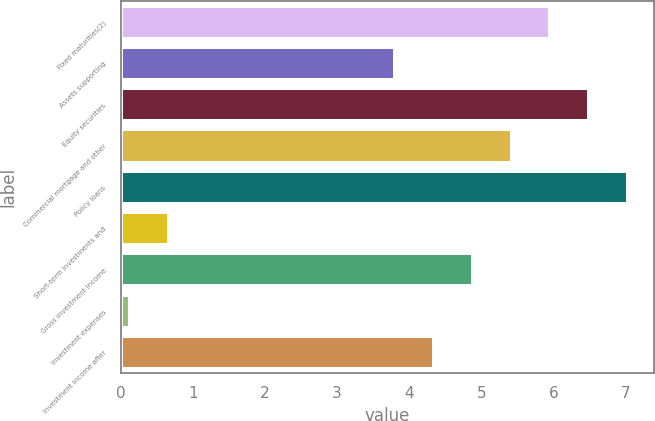Convert chart. <chart><loc_0><loc_0><loc_500><loc_500><bar_chart><fcel>Fixed maturities(2)<fcel>Assets supporting<fcel>Equity securities<fcel>Commercial mortgage and other<fcel>Policy loans<fcel>Short-term investments and<fcel>Gross investment income<fcel>Investment expenses<fcel>Investment income after<nl><fcel>5.96<fcel>3.8<fcel>6.5<fcel>5.42<fcel>7.04<fcel>0.67<fcel>4.88<fcel>0.13<fcel>4.34<nl></chart> 